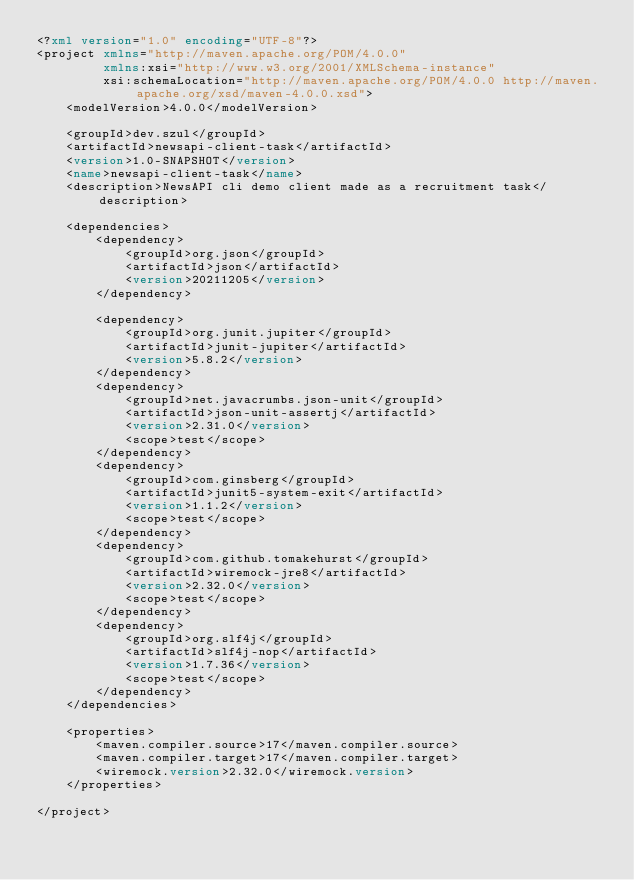<code> <loc_0><loc_0><loc_500><loc_500><_XML_><?xml version="1.0" encoding="UTF-8"?>
<project xmlns="http://maven.apache.org/POM/4.0.0"
         xmlns:xsi="http://www.w3.org/2001/XMLSchema-instance"
         xsi:schemaLocation="http://maven.apache.org/POM/4.0.0 http://maven.apache.org/xsd/maven-4.0.0.xsd">
    <modelVersion>4.0.0</modelVersion>

    <groupId>dev.szul</groupId>
    <artifactId>newsapi-client-task</artifactId>
    <version>1.0-SNAPSHOT</version>
    <name>newsapi-client-task</name>
    <description>NewsAPI cli demo client made as a recruitment task</description>

    <dependencies>
        <dependency>
            <groupId>org.json</groupId>
            <artifactId>json</artifactId>
            <version>20211205</version>
        </dependency>

        <dependency>
            <groupId>org.junit.jupiter</groupId>
            <artifactId>junit-jupiter</artifactId>
            <version>5.8.2</version>
        </dependency>
        <dependency>
            <groupId>net.javacrumbs.json-unit</groupId>
            <artifactId>json-unit-assertj</artifactId>
            <version>2.31.0</version>
            <scope>test</scope>
        </dependency>
        <dependency>
            <groupId>com.ginsberg</groupId>
            <artifactId>junit5-system-exit</artifactId>
            <version>1.1.2</version>
            <scope>test</scope>
        </dependency>
        <dependency>
            <groupId>com.github.tomakehurst</groupId>
            <artifactId>wiremock-jre8</artifactId>
            <version>2.32.0</version>
            <scope>test</scope>
        </dependency>
        <dependency>
            <groupId>org.slf4j</groupId>
            <artifactId>slf4j-nop</artifactId>
            <version>1.7.36</version>
            <scope>test</scope>
        </dependency>
    </dependencies>

    <properties>
        <maven.compiler.source>17</maven.compiler.source>
        <maven.compiler.target>17</maven.compiler.target>
        <wiremock.version>2.32.0</wiremock.version>
    </properties>

</project>
</code> 